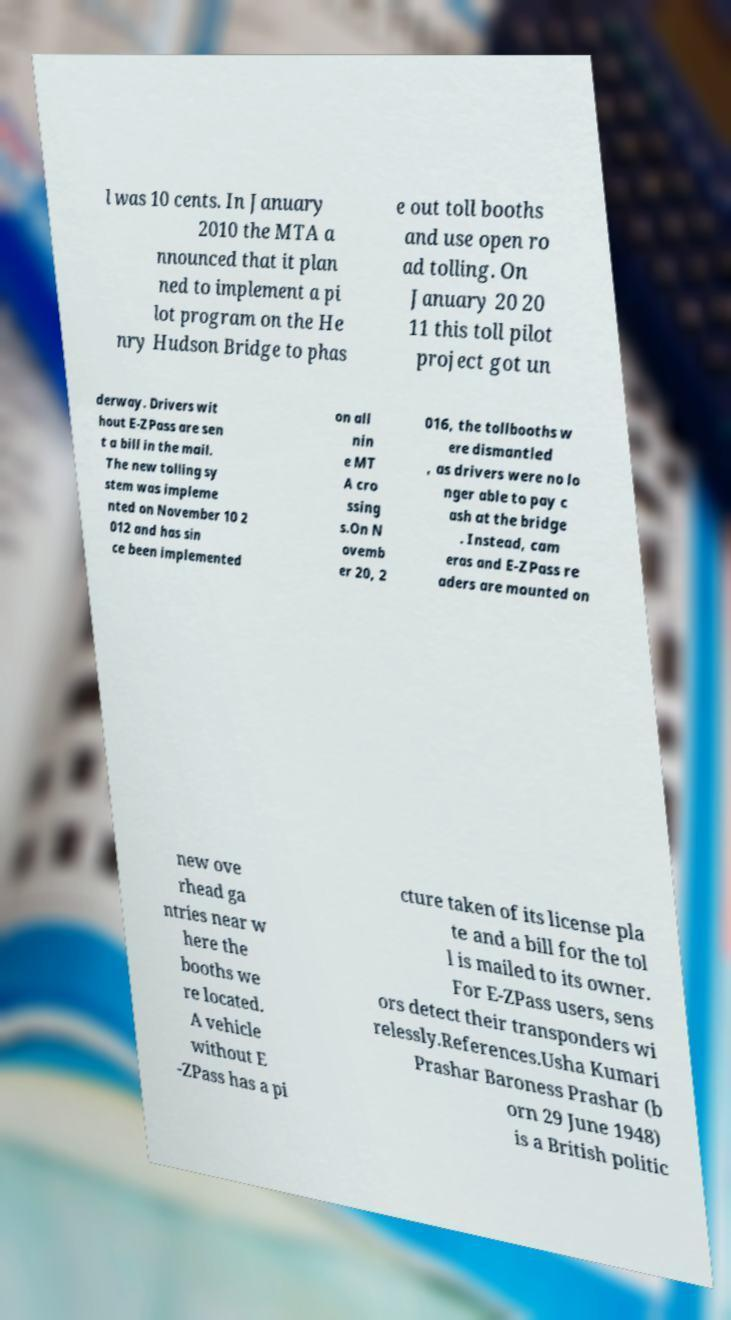Could you assist in decoding the text presented in this image and type it out clearly? l was 10 cents. In January 2010 the MTA a nnounced that it plan ned to implement a pi lot program on the He nry Hudson Bridge to phas e out toll booths and use open ro ad tolling. On January 20 20 11 this toll pilot project got un derway. Drivers wit hout E-ZPass are sen t a bill in the mail. The new tolling sy stem was impleme nted on November 10 2 012 and has sin ce been implemented on all nin e MT A cro ssing s.On N ovemb er 20, 2 016, the tollbooths w ere dismantled , as drivers were no lo nger able to pay c ash at the bridge . Instead, cam eras and E-ZPass re aders are mounted on new ove rhead ga ntries near w here the booths we re located. A vehicle without E -ZPass has a pi cture taken of its license pla te and a bill for the tol l is mailed to its owner. For E-ZPass users, sens ors detect their transponders wi relessly.References.Usha Kumari Prashar Baroness Prashar (b orn 29 June 1948) is a British politic 